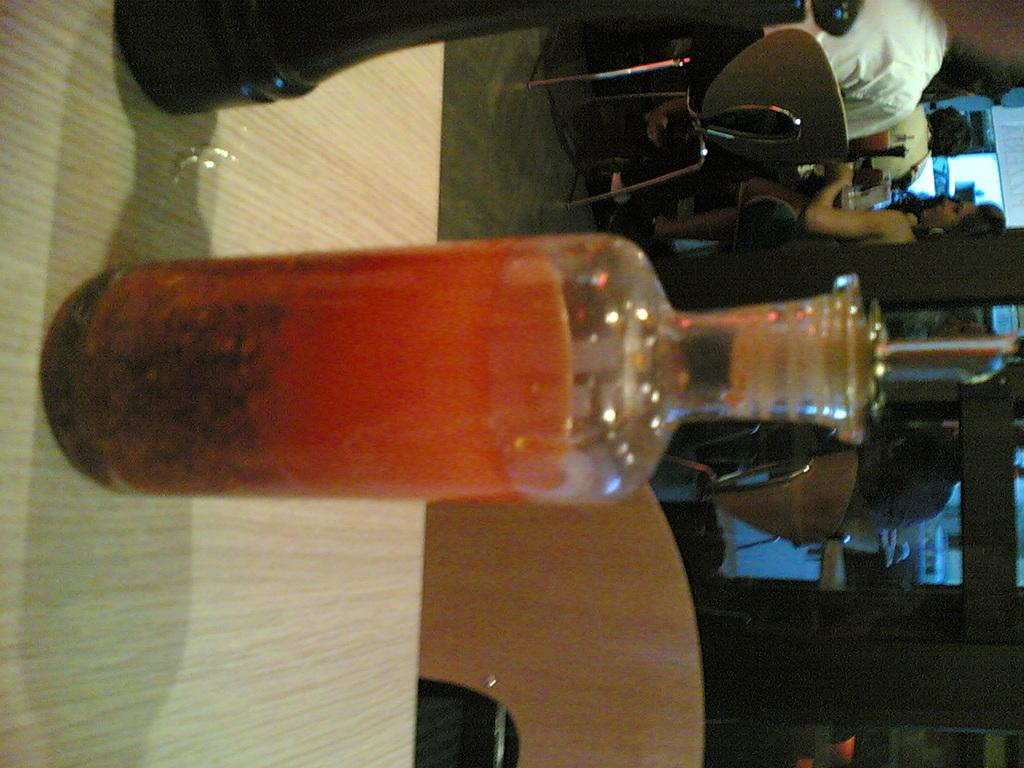What object is on the table in the image? There is a glass bottle on the table. Where are the people in the image located in relation to the table? The group of people is sitting on chairs to the right of the table. How does the wind affect the digestion of the people in the image? There is no mention of wind or digestion in the image, so it is not possible to answer that question. 